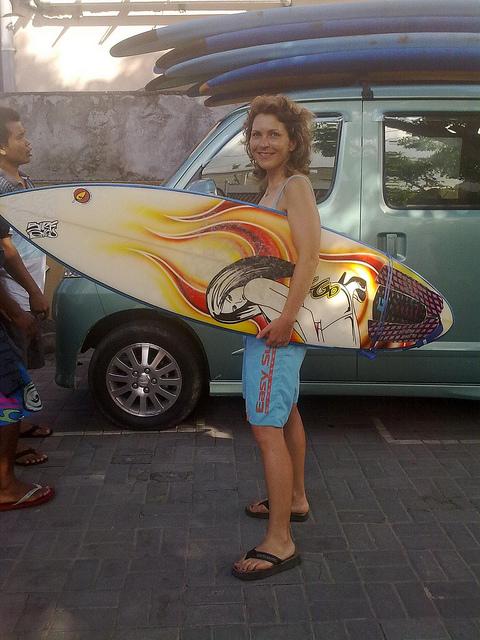What color are her flip flops?
Give a very brief answer. Black. What sport is the lady likely participating in?
Answer briefly. Surfing. Is everyone wearing flip flops on their feet?
Give a very brief answer. Yes. 